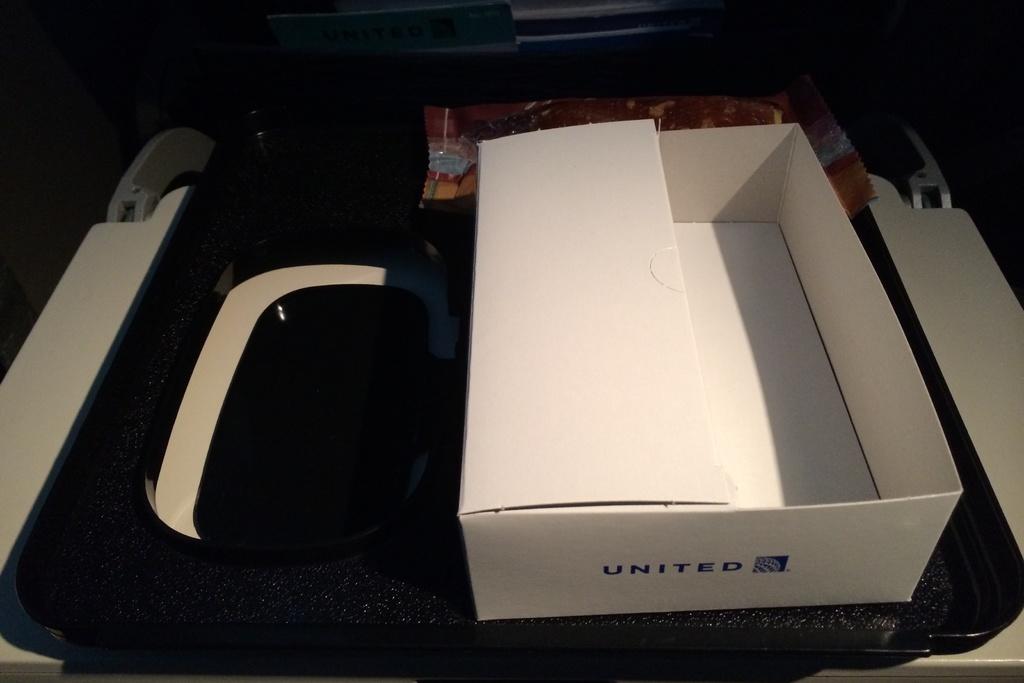What name is on the front of the box?
Provide a short and direct response. United. 